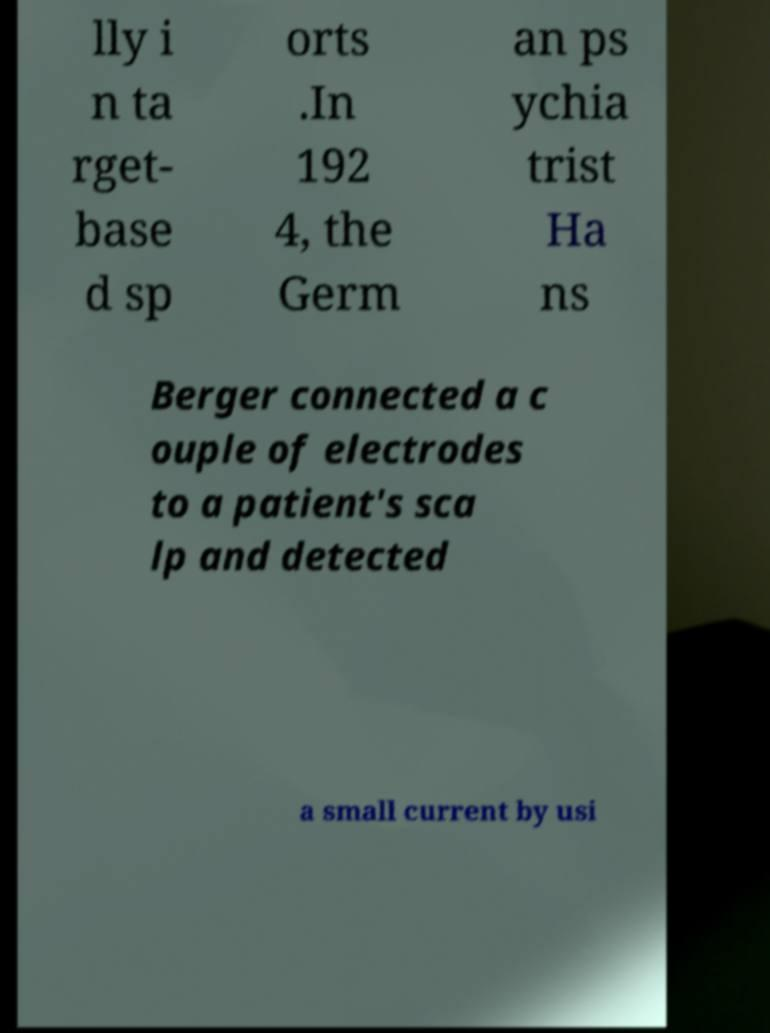Please identify and transcribe the text found in this image. lly i n ta rget- base d sp orts .In 192 4, the Germ an ps ychia trist Ha ns Berger connected a c ouple of electrodes to a patient's sca lp and detected a small current by usi 